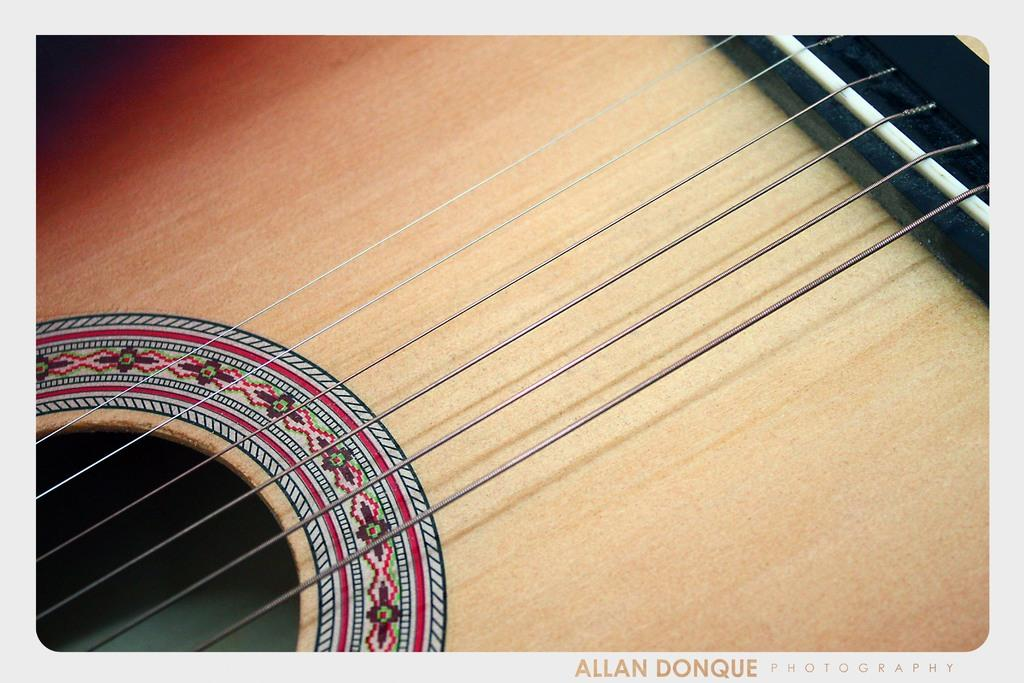What musical instrument is present in the image? There is a guitar in the image. Can you describe the guitar in more detail? Unfortunately, the image only shows the guitar, and no additional details are provided. How many cherries are on the leaf of the guitar in the image? There are no cherries or leaves present on the guitar in the image. 